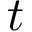<formula> <loc_0><loc_0><loc_500><loc_500>t</formula> 